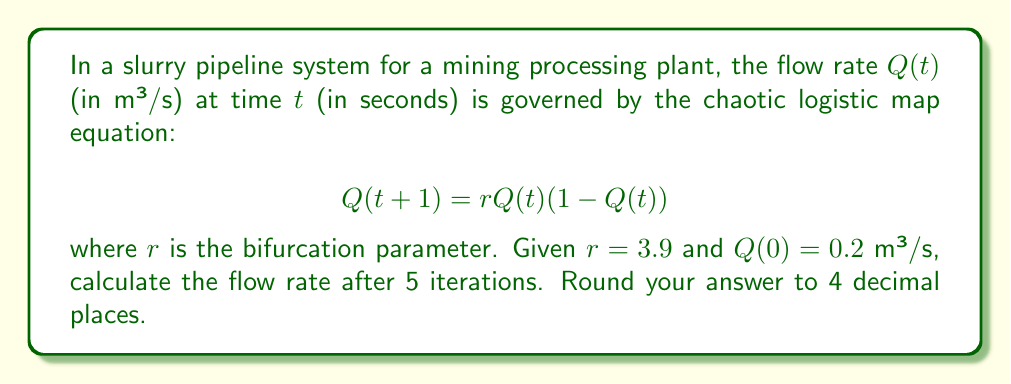What is the answer to this math problem? To solve this problem, we need to iterate the logistic map equation 5 times:

1. For $t = 0$:
   $Q(1) = 3.9 \cdot 0.2 \cdot (1 - 0.2) = 0.624$ m³/s

2. For $t = 1$:
   $Q(2) = 3.9 \cdot 0.624 \cdot (1 - 0.624) = 0.9165$ m³/s

3. For $t = 2$:
   $Q(3) = 3.9 \cdot 0.9165 \cdot (1 - 0.9165) = 0.2990$ m³/s

4. For $t = 3$:
   $Q(4) = 3.9 \cdot 0.2990 \cdot (1 - 0.2990) = 0.8187$ m³/s

5. For $t = 4$:
   $Q(5) = 3.9 \cdot 0.8187 \cdot (1 - 0.8187) = 0.5791$ m³/s

Rounding the final result to 4 decimal places gives 0.5791 m³/s.
Answer: 0.5791 m³/s 